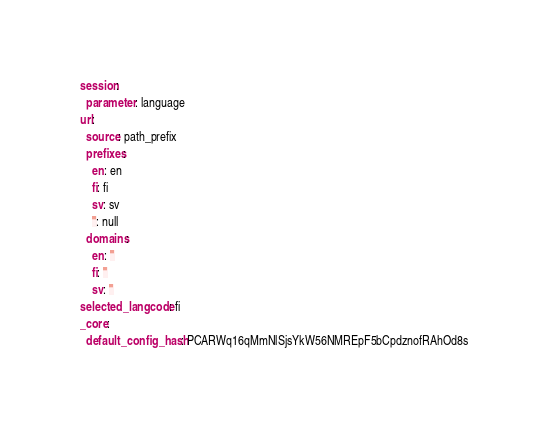Convert code to text. <code><loc_0><loc_0><loc_500><loc_500><_YAML_>session:
  parameter: language
url:
  source: path_prefix
  prefixes:
    en: en
    fi: fi
    sv: sv
    '': null
  domains:
    en: ''
    fi: ''
    sv: ''
selected_langcode: fi
_core:
  default_config_hash: PCARWq16qMmNlSjsYkW56NMREpF5bCpdznofRAhOd8s
</code> 